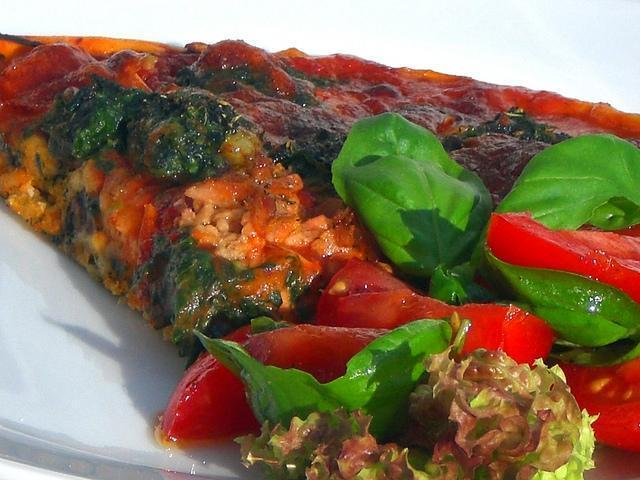How many broccolis are there?
Give a very brief answer. 3. How many people are holding camera?
Give a very brief answer. 0. 